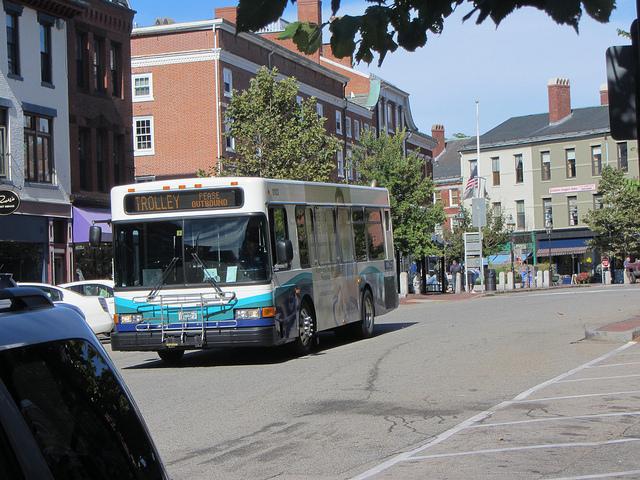Are there passengers on the bus?
Keep it brief. Yes. Is the bus in motion?
Keep it brief. Yes. Why are there brick rectangles coming out of the roofs?
Quick response, please. Chimneys. 